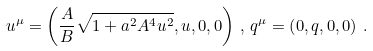Convert formula to latex. <formula><loc_0><loc_0><loc_500><loc_500>u ^ { \mu } = \left ( \frac { A } { B } \sqrt { 1 + a ^ { 2 } A ^ { 4 } u ^ { 2 } } , u , 0 , 0 \right ) \, , \, q ^ { \mu } = \left ( 0 , q , 0 , 0 \right ) \, .</formula> 